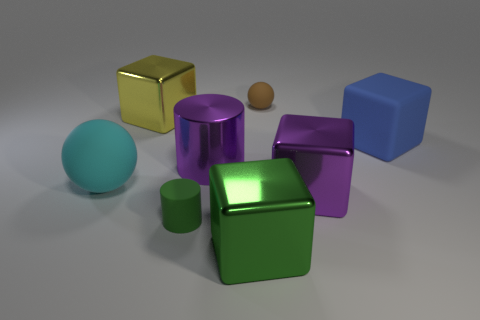Is the number of large purple cylinders left of the big cyan matte ball the same as the number of shiny cylinders that are on the right side of the tiny green cylinder?
Your answer should be compact. No. There is a small object in front of the blue rubber block; what is its shape?
Keep it short and to the point. Cylinder. What shape is the yellow metal object that is the same size as the cyan object?
Offer a very short reply. Cube. What color is the small rubber object behind the purple metallic thing left of the object behind the large yellow shiny cube?
Your response must be concise. Brown. Is the brown matte thing the same shape as the big yellow thing?
Give a very brief answer. No. Is the number of big purple metal cubes behind the purple shiny cube the same as the number of big purple matte blocks?
Your response must be concise. Yes. What number of other things are the same material as the yellow block?
Ensure brevity in your answer.  3. Is the size of the matte object that is to the left of the small matte cylinder the same as the shiny block behind the purple cube?
Your answer should be very brief. Yes. How many objects are either big metallic objects behind the large blue cube or large metal blocks that are on the left side of the green rubber thing?
Give a very brief answer. 1. There is a large thing that is in front of the small cylinder; is it the same color as the small object that is on the left side of the green block?
Your response must be concise. Yes. 